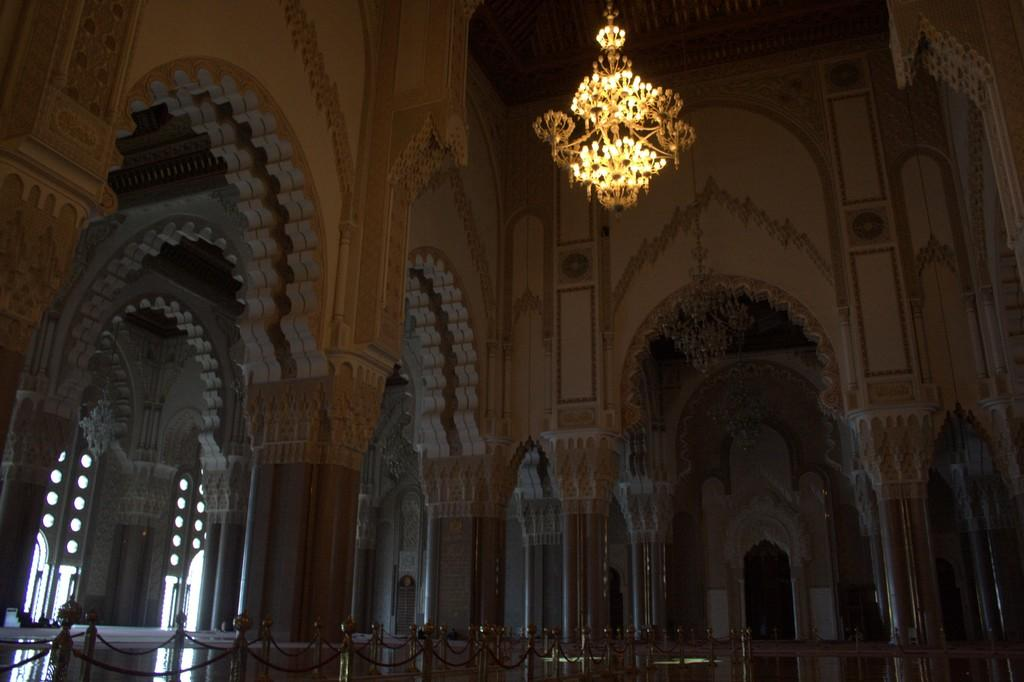What type of structure can be seen in the image? There is a fence, pillars, and a wall visible in the image, which suggests a palace-like structure. Can you describe any architectural features in the image? Yes, there is a chandelier visible in the image, which is a common feature in palaces. Is there anyone present in the image? Yes, there is a person in the image. What time of day is the image likely taken? The image is likely taken during the day, as there is sufficient natural light visible. Can you tell me how many monkeys are sitting on the chandelier in the image? There are no monkeys present in the image; only a person and various architectural features can be seen. What type of cup is being used by the person in the image? There is no cup visible in the image; the person is not holding or interacting with any objects. 